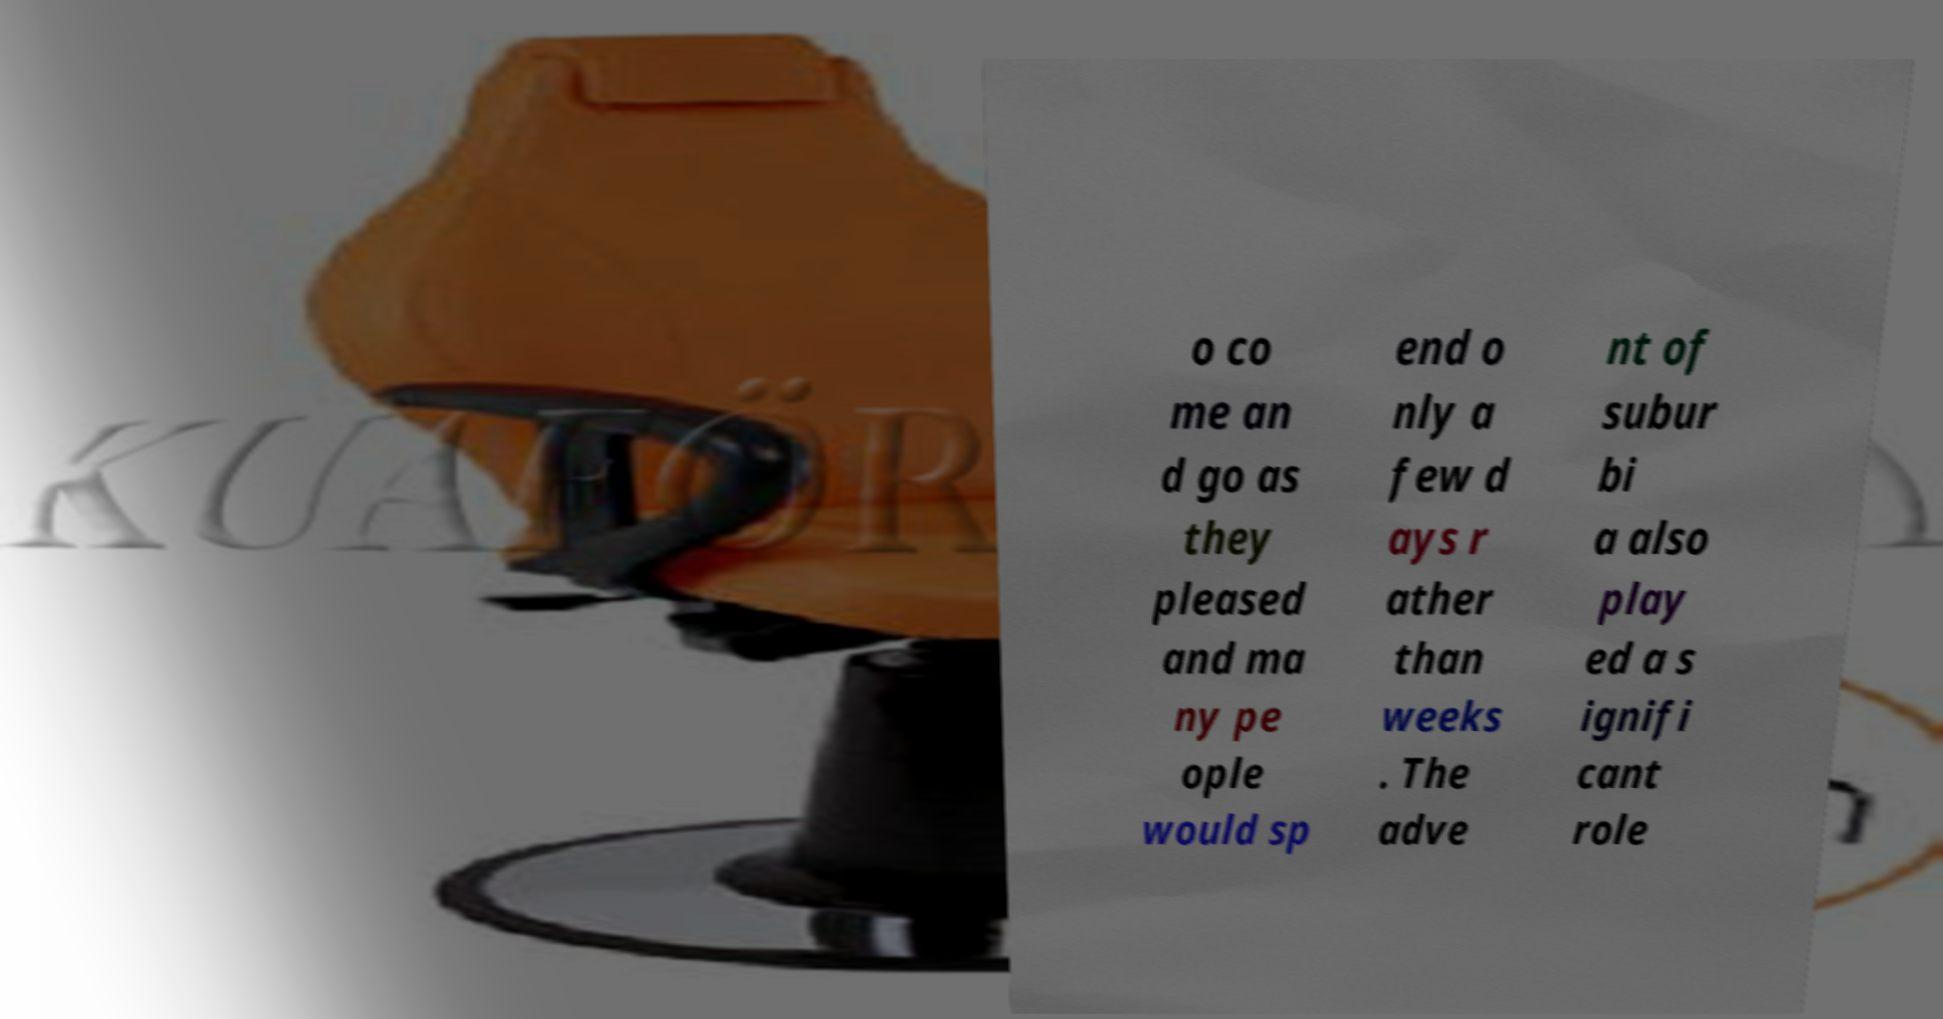There's text embedded in this image that I need extracted. Can you transcribe it verbatim? o co me an d go as they pleased and ma ny pe ople would sp end o nly a few d ays r ather than weeks . The adve nt of subur bi a also play ed a s ignifi cant role 